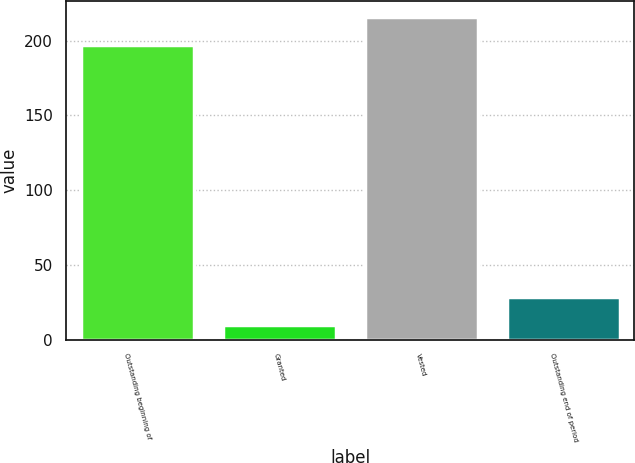Convert chart to OTSL. <chart><loc_0><loc_0><loc_500><loc_500><bar_chart><fcel>Outstanding beginning of<fcel>Granted<fcel>Vested<fcel>Outstanding end of period<nl><fcel>197<fcel>10<fcel>215.7<fcel>28.7<nl></chart> 